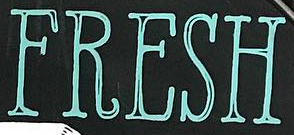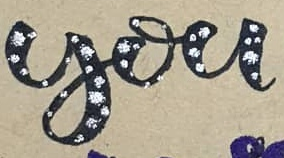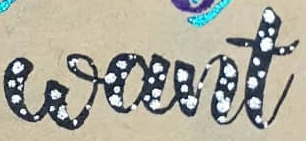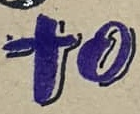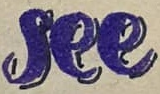What words can you see in these images in sequence, separated by a semicolon? FRESH; you; want; to; see 